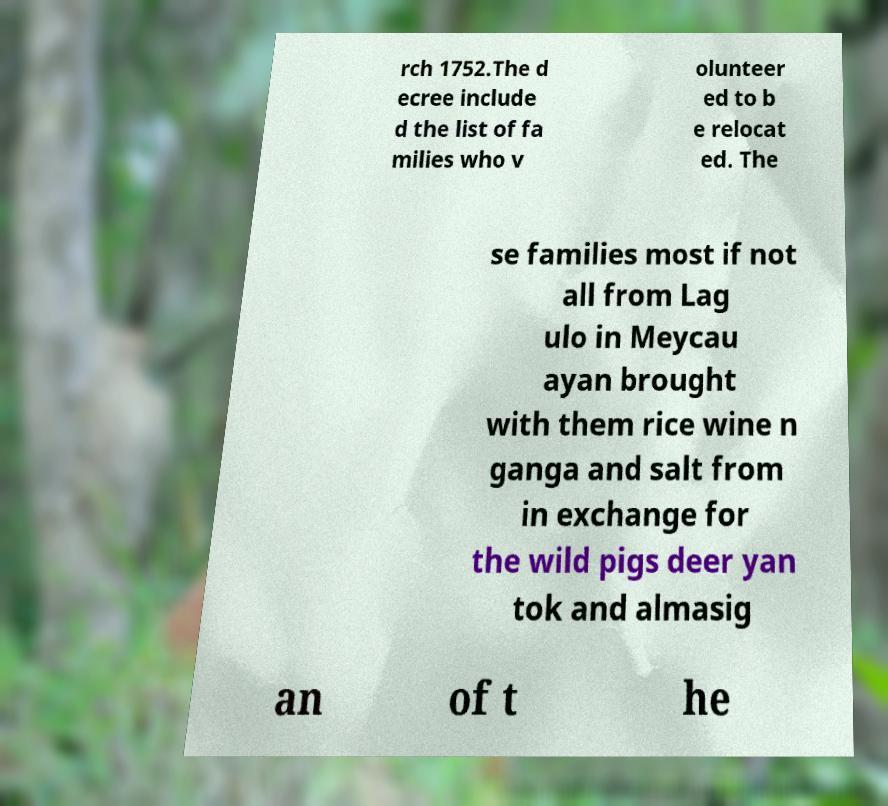Please read and relay the text visible in this image. What does it say? rch 1752.The d ecree include d the list of fa milies who v olunteer ed to b e relocat ed. The se families most if not all from Lag ulo in Meycau ayan brought with them rice wine n ganga and salt from in exchange for the wild pigs deer yan tok and almasig an of t he 